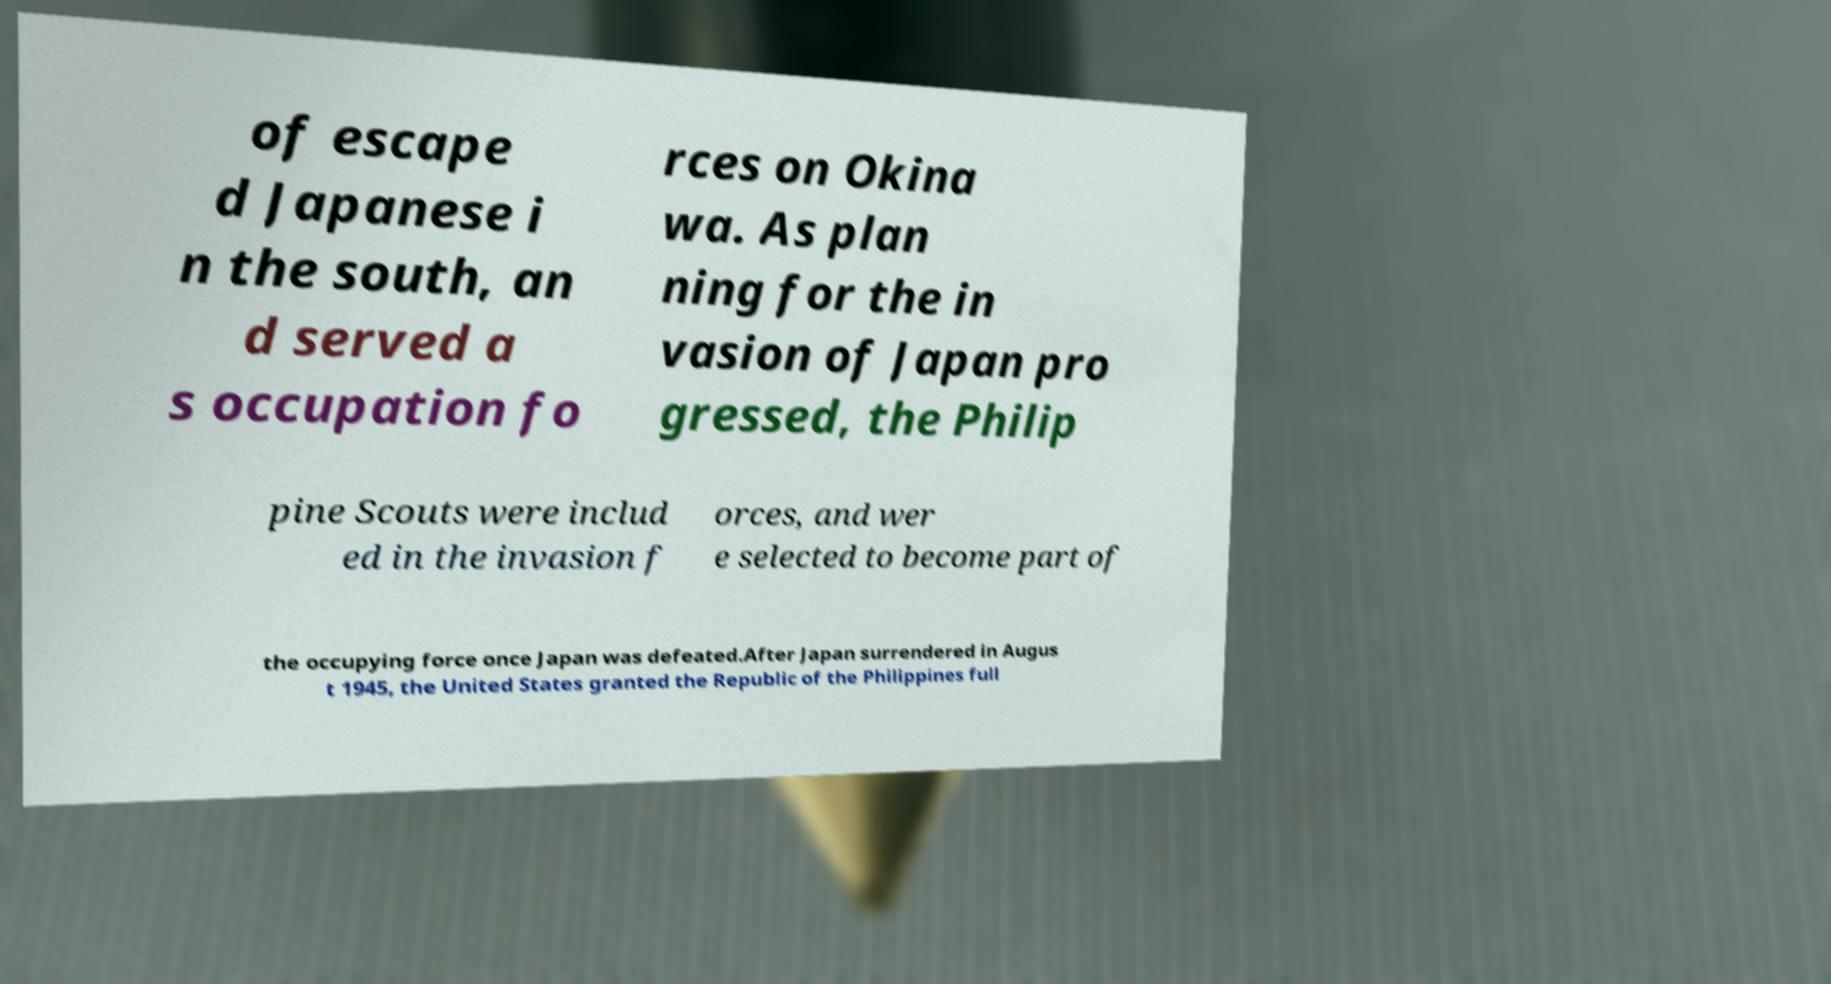For documentation purposes, I need the text within this image transcribed. Could you provide that? of escape d Japanese i n the south, an d served a s occupation fo rces on Okina wa. As plan ning for the in vasion of Japan pro gressed, the Philip pine Scouts were includ ed in the invasion f orces, and wer e selected to become part of the occupying force once Japan was defeated.After Japan surrendered in Augus t 1945, the United States granted the Republic of the Philippines full 